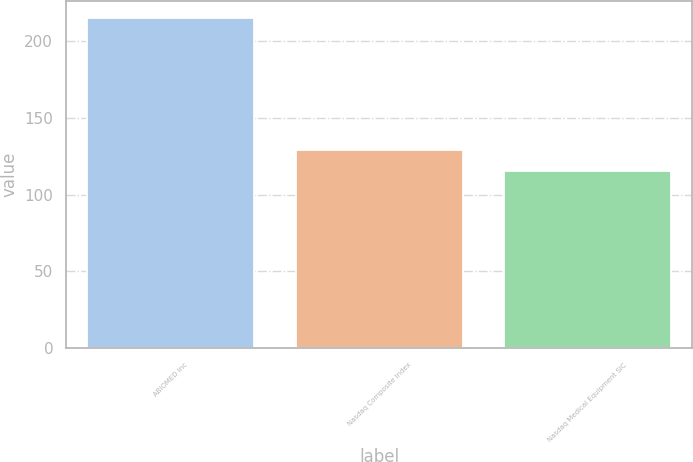Convert chart. <chart><loc_0><loc_0><loc_500><loc_500><bar_chart><fcel>ABIOMED Inc<fcel>Nasdaq Composite Index<fcel>Nasdaq Medical Equipment SIC<nl><fcel>215.02<fcel>128.93<fcel>115.05<nl></chart> 